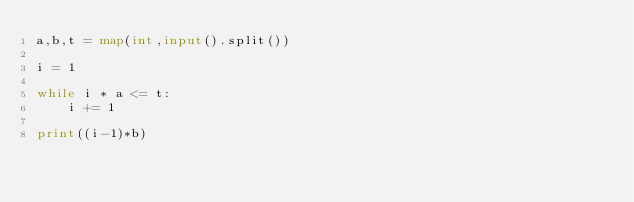Convert code to text. <code><loc_0><loc_0><loc_500><loc_500><_Python_>a,b,t = map(int,input().split())

i = 1

while i * a <= t:
	i += 1

print((i-1)*b)
	
	
</code> 